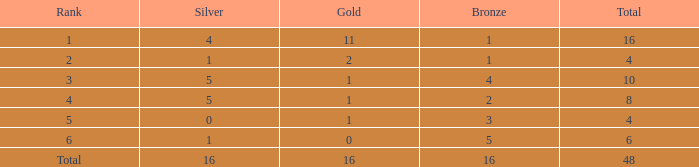How many total gold are less than 4? 0.0. 